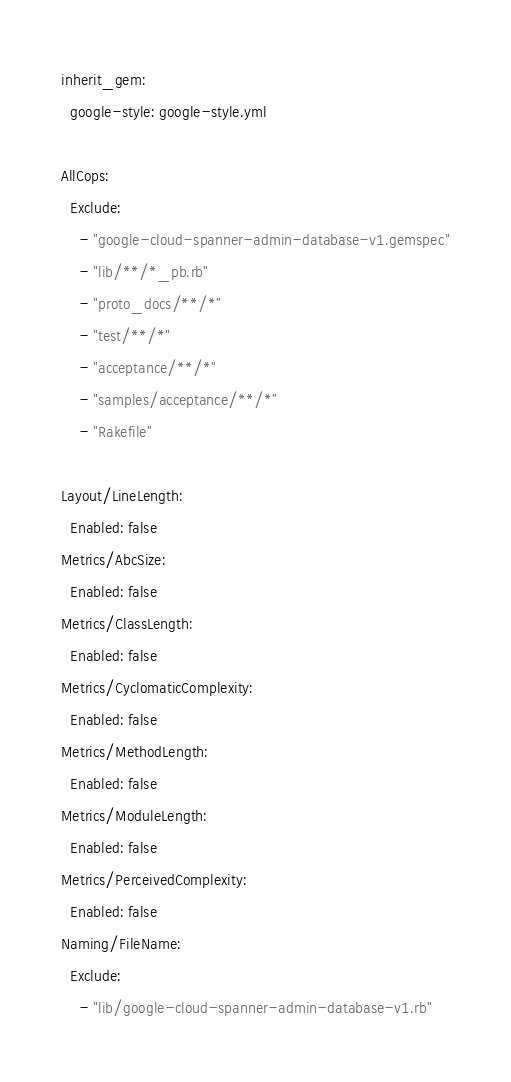Convert code to text. <code><loc_0><loc_0><loc_500><loc_500><_YAML_>inherit_gem:
  google-style: google-style.yml

AllCops:
  Exclude:
    - "google-cloud-spanner-admin-database-v1.gemspec"
    - "lib/**/*_pb.rb"
    - "proto_docs/**/*"
    - "test/**/*"
    - "acceptance/**/*"
    - "samples/acceptance/**/*"
    - "Rakefile"

Layout/LineLength:
  Enabled: false
Metrics/AbcSize:
  Enabled: false
Metrics/ClassLength:
  Enabled: false
Metrics/CyclomaticComplexity:
  Enabled: false
Metrics/MethodLength:
  Enabled: false
Metrics/ModuleLength:
  Enabled: false
Metrics/PerceivedComplexity:
  Enabled: false
Naming/FileName:
  Exclude:
    - "lib/google-cloud-spanner-admin-database-v1.rb"
</code> 